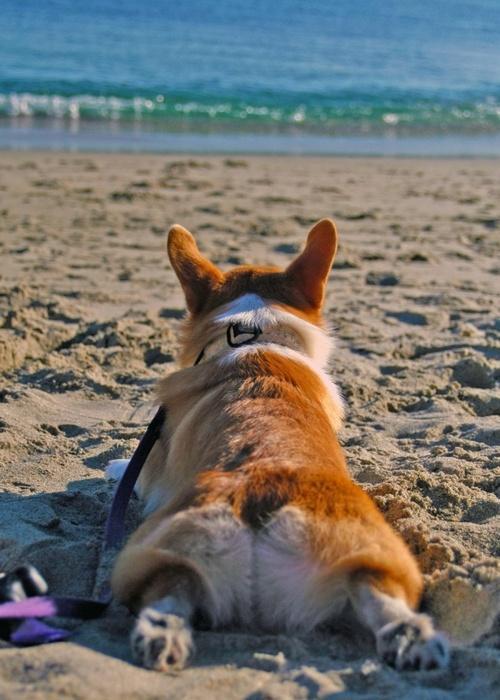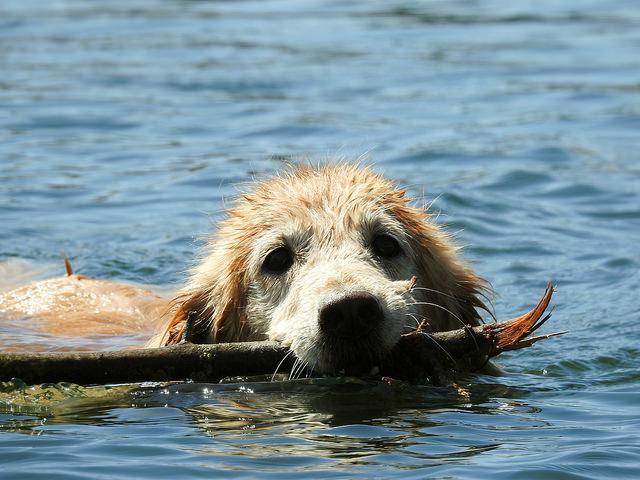The first image is the image on the left, the second image is the image on the right. For the images shown, is this caption "One image shows at least one dog swimming forward with nothing carried in its mouth, and the other image contains one sitting dog wearing a leash." true? Answer yes or no. No. The first image is the image on the left, the second image is the image on the right. For the images shown, is this caption "One of the dogs has a stick in its mouth." true? Answer yes or no. Yes. 